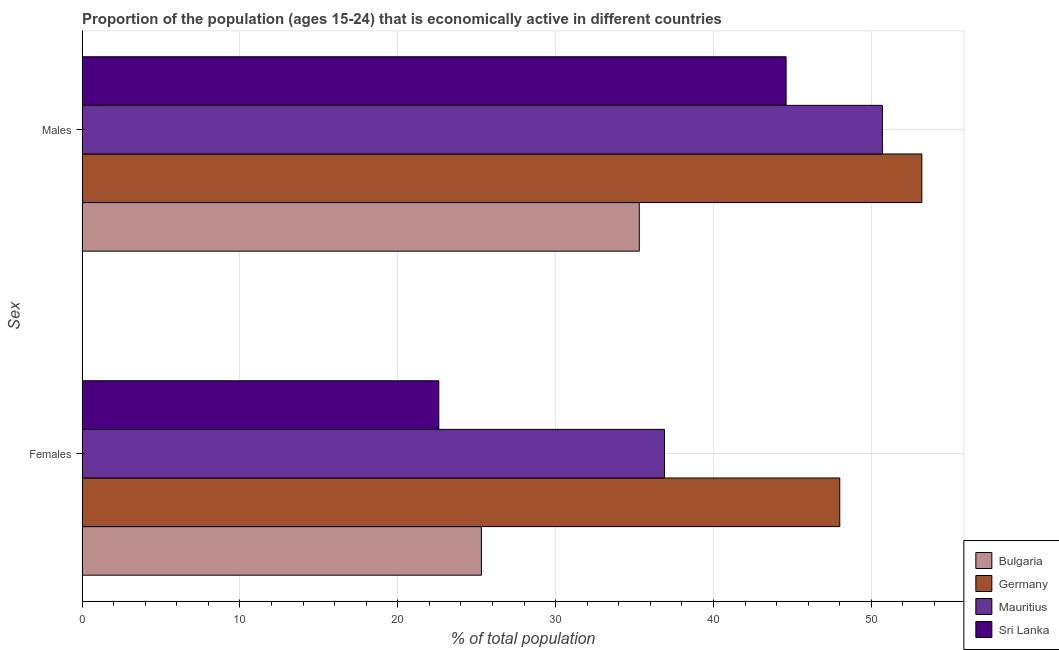How many different coloured bars are there?
Keep it short and to the point. 4. Are the number of bars per tick equal to the number of legend labels?
Offer a terse response. Yes. Are the number of bars on each tick of the Y-axis equal?
Give a very brief answer. Yes. How many bars are there on the 2nd tick from the top?
Offer a terse response. 4. What is the label of the 1st group of bars from the top?
Offer a very short reply. Males. What is the percentage of economically active female population in Bulgaria?
Your answer should be compact. 25.3. Across all countries, what is the maximum percentage of economically active female population?
Your answer should be very brief. 48. Across all countries, what is the minimum percentage of economically active female population?
Keep it short and to the point. 22.6. In which country was the percentage of economically active female population minimum?
Your response must be concise. Sri Lanka. What is the total percentage of economically active male population in the graph?
Ensure brevity in your answer.  183.8. What is the difference between the percentage of economically active male population in Mauritius and that in Sri Lanka?
Your response must be concise. 6.1. What is the difference between the percentage of economically active male population in Sri Lanka and the percentage of economically active female population in Bulgaria?
Give a very brief answer. 19.3. What is the average percentage of economically active male population per country?
Your answer should be very brief. 45.95. What is the difference between the percentage of economically active male population and percentage of economically active female population in Sri Lanka?
Make the answer very short. 22. What is the ratio of the percentage of economically active male population in Bulgaria to that in Germany?
Offer a very short reply. 0.66. What does the 3rd bar from the bottom in Males represents?
Your answer should be compact. Mauritius. Are all the bars in the graph horizontal?
Offer a very short reply. Yes. How many countries are there in the graph?
Offer a terse response. 4. Are the values on the major ticks of X-axis written in scientific E-notation?
Make the answer very short. No. Does the graph contain any zero values?
Your answer should be compact. No. Does the graph contain grids?
Offer a very short reply. Yes. Where does the legend appear in the graph?
Your answer should be compact. Bottom right. What is the title of the graph?
Keep it short and to the point. Proportion of the population (ages 15-24) that is economically active in different countries. What is the label or title of the X-axis?
Your answer should be very brief. % of total population. What is the label or title of the Y-axis?
Ensure brevity in your answer.  Sex. What is the % of total population in Bulgaria in Females?
Your answer should be compact. 25.3. What is the % of total population in Germany in Females?
Make the answer very short. 48. What is the % of total population in Mauritius in Females?
Offer a very short reply. 36.9. What is the % of total population in Sri Lanka in Females?
Offer a very short reply. 22.6. What is the % of total population in Bulgaria in Males?
Provide a succinct answer. 35.3. What is the % of total population in Germany in Males?
Provide a short and direct response. 53.2. What is the % of total population of Mauritius in Males?
Your answer should be very brief. 50.7. What is the % of total population of Sri Lanka in Males?
Provide a succinct answer. 44.6. Across all Sex, what is the maximum % of total population of Bulgaria?
Provide a short and direct response. 35.3. Across all Sex, what is the maximum % of total population of Germany?
Your response must be concise. 53.2. Across all Sex, what is the maximum % of total population of Mauritius?
Ensure brevity in your answer.  50.7. Across all Sex, what is the maximum % of total population of Sri Lanka?
Give a very brief answer. 44.6. Across all Sex, what is the minimum % of total population of Bulgaria?
Give a very brief answer. 25.3. Across all Sex, what is the minimum % of total population of Mauritius?
Ensure brevity in your answer.  36.9. Across all Sex, what is the minimum % of total population of Sri Lanka?
Keep it short and to the point. 22.6. What is the total % of total population in Bulgaria in the graph?
Offer a terse response. 60.6. What is the total % of total population of Germany in the graph?
Ensure brevity in your answer.  101.2. What is the total % of total population of Mauritius in the graph?
Keep it short and to the point. 87.6. What is the total % of total population of Sri Lanka in the graph?
Your answer should be very brief. 67.2. What is the difference between the % of total population in Bulgaria in Females and that in Males?
Make the answer very short. -10. What is the difference between the % of total population of Germany in Females and that in Males?
Your response must be concise. -5.2. What is the difference between the % of total population of Sri Lanka in Females and that in Males?
Your response must be concise. -22. What is the difference between the % of total population in Bulgaria in Females and the % of total population in Germany in Males?
Your answer should be compact. -27.9. What is the difference between the % of total population in Bulgaria in Females and the % of total population in Mauritius in Males?
Keep it short and to the point. -25.4. What is the difference between the % of total population of Bulgaria in Females and the % of total population of Sri Lanka in Males?
Provide a short and direct response. -19.3. What is the difference between the % of total population in Germany in Females and the % of total population in Mauritius in Males?
Your answer should be very brief. -2.7. What is the difference between the % of total population in Germany in Females and the % of total population in Sri Lanka in Males?
Provide a short and direct response. 3.4. What is the average % of total population of Bulgaria per Sex?
Make the answer very short. 30.3. What is the average % of total population of Germany per Sex?
Ensure brevity in your answer.  50.6. What is the average % of total population of Mauritius per Sex?
Provide a short and direct response. 43.8. What is the average % of total population of Sri Lanka per Sex?
Provide a short and direct response. 33.6. What is the difference between the % of total population in Bulgaria and % of total population in Germany in Females?
Provide a succinct answer. -22.7. What is the difference between the % of total population of Bulgaria and % of total population of Mauritius in Females?
Your response must be concise. -11.6. What is the difference between the % of total population of Germany and % of total population of Mauritius in Females?
Make the answer very short. 11.1. What is the difference between the % of total population of Germany and % of total population of Sri Lanka in Females?
Offer a very short reply. 25.4. What is the difference between the % of total population of Bulgaria and % of total population of Germany in Males?
Make the answer very short. -17.9. What is the difference between the % of total population of Bulgaria and % of total population of Mauritius in Males?
Offer a terse response. -15.4. What is the ratio of the % of total population of Bulgaria in Females to that in Males?
Offer a very short reply. 0.72. What is the ratio of the % of total population of Germany in Females to that in Males?
Make the answer very short. 0.9. What is the ratio of the % of total population in Mauritius in Females to that in Males?
Your response must be concise. 0.73. What is the ratio of the % of total population of Sri Lanka in Females to that in Males?
Give a very brief answer. 0.51. What is the difference between the highest and the second highest % of total population of Sri Lanka?
Offer a very short reply. 22. What is the difference between the highest and the lowest % of total population of Mauritius?
Make the answer very short. 13.8. What is the difference between the highest and the lowest % of total population of Sri Lanka?
Ensure brevity in your answer.  22. 